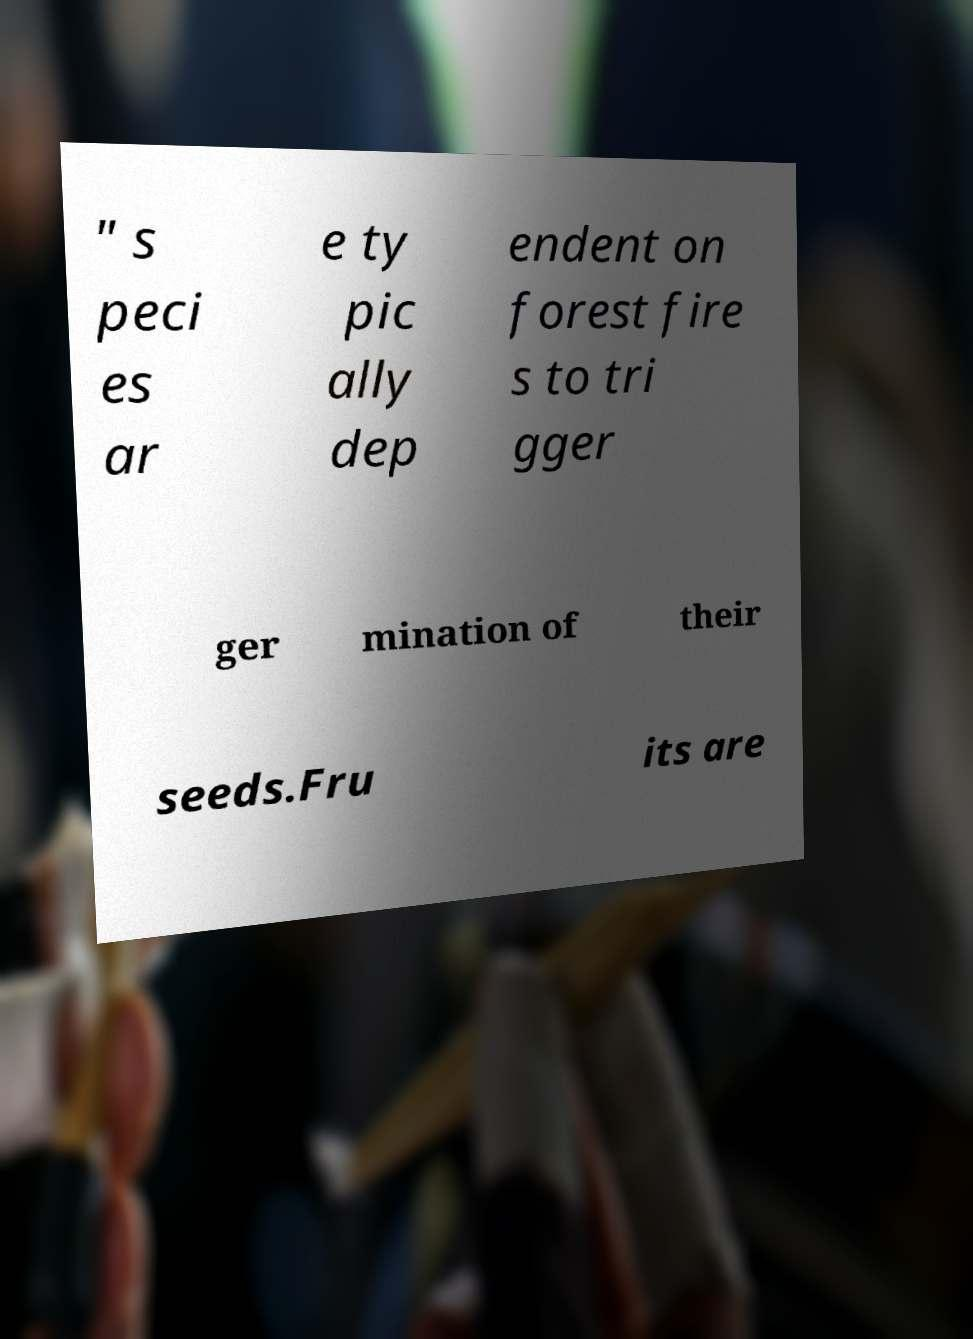What messages or text are displayed in this image? I need them in a readable, typed format. " s peci es ar e ty pic ally dep endent on forest fire s to tri gger ger mination of their seeds.Fru its are 